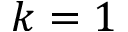Convert formula to latex. <formula><loc_0><loc_0><loc_500><loc_500>k = 1</formula> 